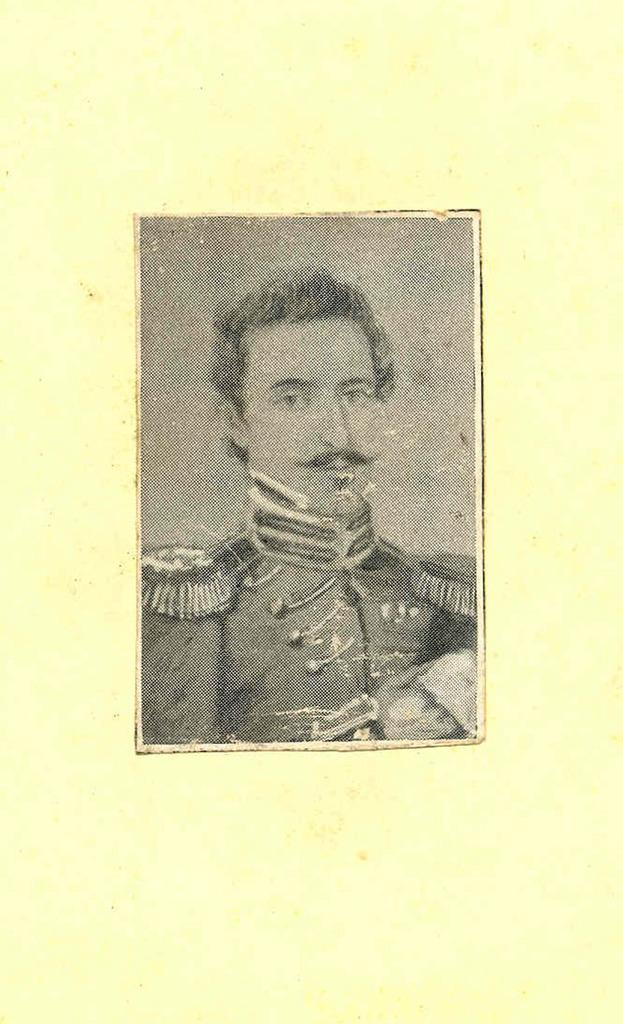What is present on the paper in the image? There is a man depicted on the paper. Can you describe the man on the paper? Unfortunately, the facts provided do not give any details about the man's appearance or actions. What is the primary purpose of the paper in the image? Based on the facts, we can only determine that the paper has a man depicted on it. What type of liquid can be seen flowing through the shop in the image? There is no shop or liquid present in the image; it only features a paper with a man depicted on it. 